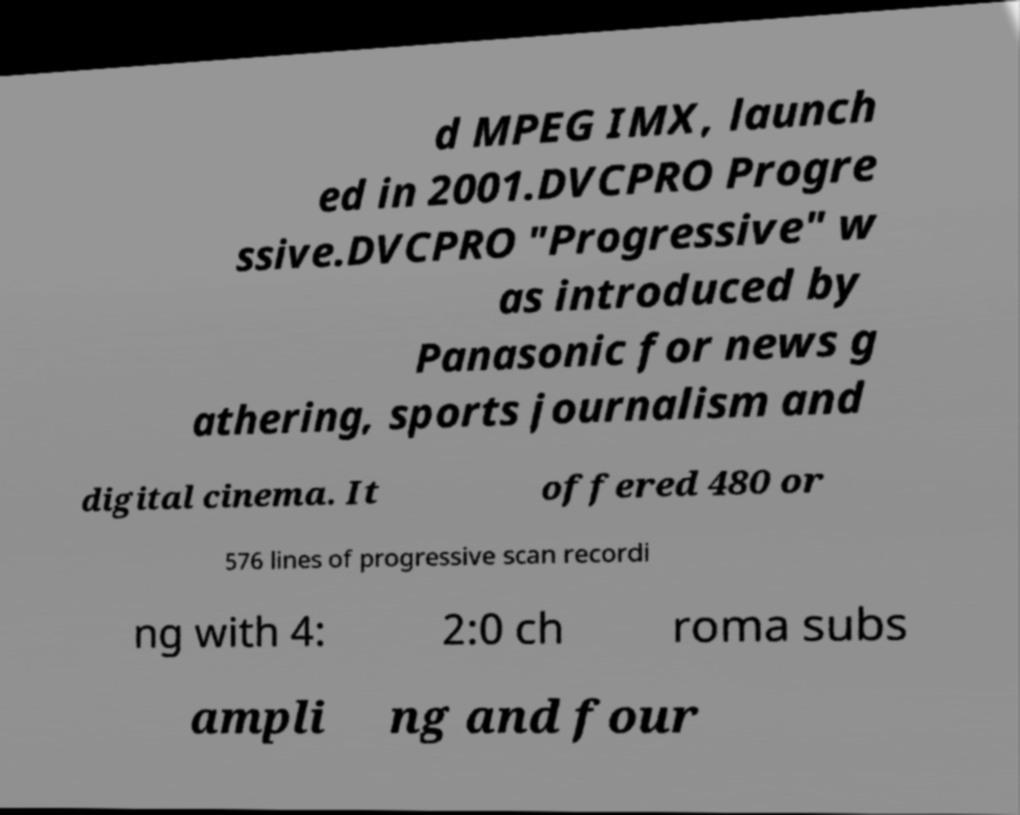For documentation purposes, I need the text within this image transcribed. Could you provide that? d MPEG IMX, launch ed in 2001.DVCPRO Progre ssive.DVCPRO "Progressive" w as introduced by Panasonic for news g athering, sports journalism and digital cinema. It offered 480 or 576 lines of progressive scan recordi ng with 4: 2:0 ch roma subs ampli ng and four 